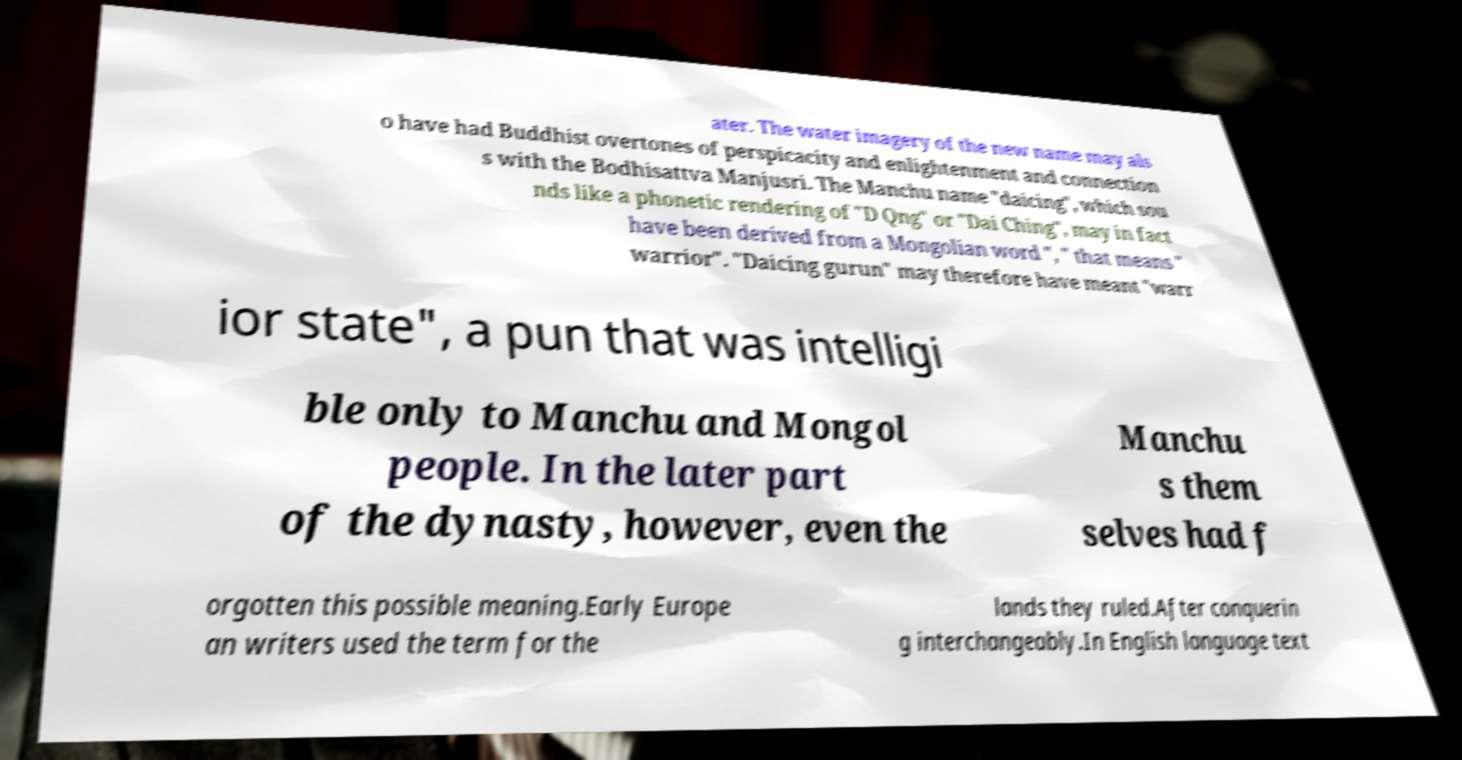There's text embedded in this image that I need extracted. Can you transcribe it verbatim? ater. The water imagery of the new name may als o have had Buddhist overtones of perspicacity and enlightenment and connection s with the Bodhisattva Manjusri. The Manchu name "daicing", which sou nds like a phonetic rendering of "D Qng" or "Dai Ching", may in fact have been derived from a Mongolian word ", " that means " warrior". "Daicing gurun" may therefore have meant "warr ior state", a pun that was intelligi ble only to Manchu and Mongol people. In the later part of the dynasty, however, even the Manchu s them selves had f orgotten this possible meaning.Early Europe an writers used the term for the lands they ruled.After conquerin g interchangeably.In English language text 